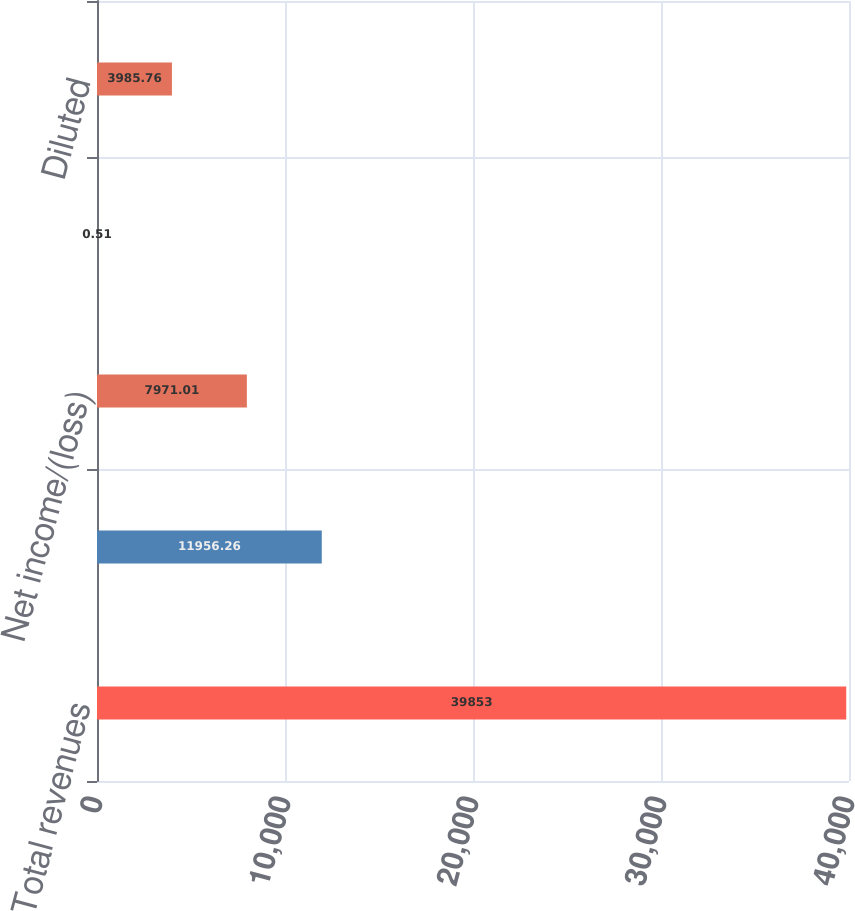Convert chart to OTSL. <chart><loc_0><loc_0><loc_500><loc_500><bar_chart><fcel>Total revenues<fcel>Income/(Loss) before income<fcel>Net income/(loss)<fcel>Basic<fcel>Diluted<nl><fcel>39853<fcel>11956.3<fcel>7971.01<fcel>0.51<fcel>3985.76<nl></chart> 